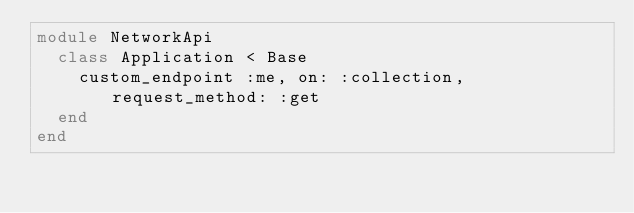Convert code to text. <code><loc_0><loc_0><loc_500><loc_500><_Ruby_>module NetworkApi
  class Application < Base
    custom_endpoint :me, on: :collection, request_method: :get
  end
end
</code> 